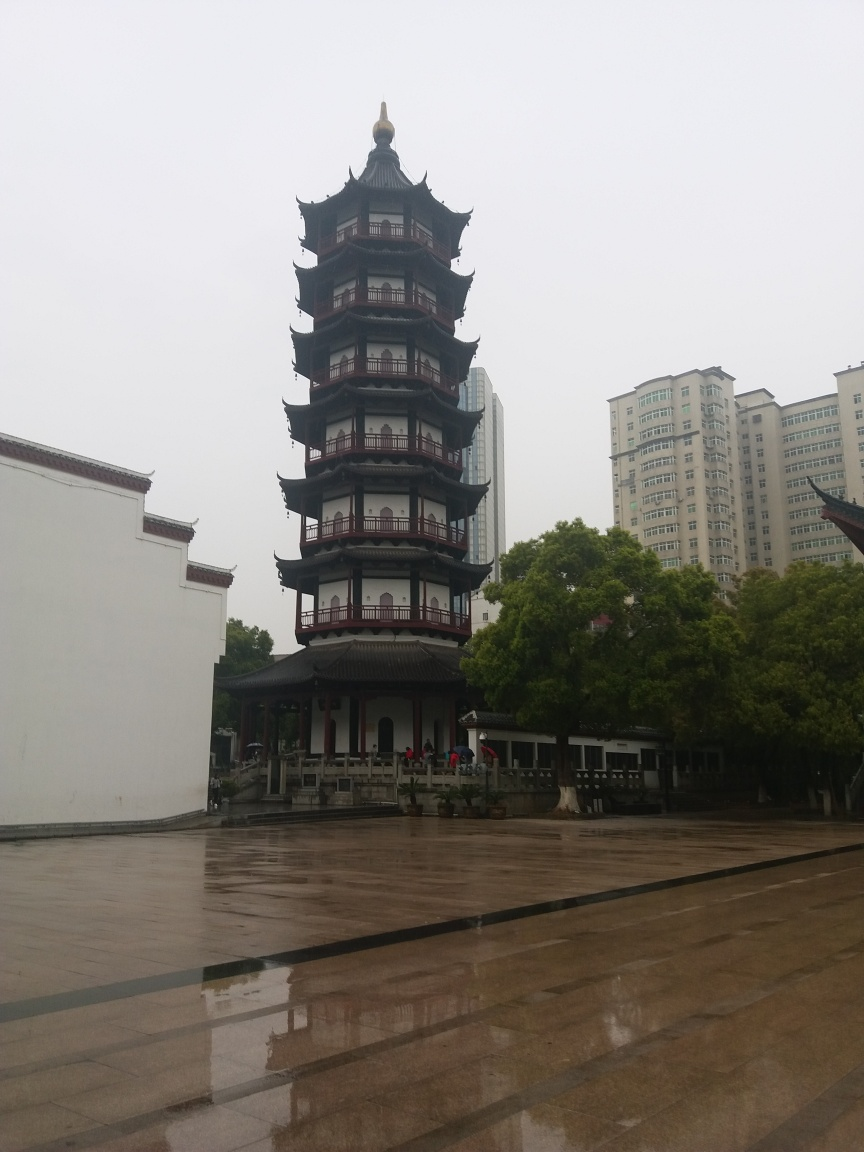Can you tell me about the weather conditions when the photo was taken? The photo appears to have been taken on an overcast day, as evidenced by the uniformly gray sky and the lack of shadows on the ground. The light is diffuse, which often happens when the sun is obscured by clouds, and the wet surfaces suggest that it might have been raining recently or that there is ongoing light rain. Does the weather affect the appearance of the image? Yes, the overcast conditions result in soft, natural lighting which eliminates harsh shadows and provides even illumination across the scene. However, this can also lead to less vibrant colors and lower contrast, making the image feel somewhat muted and lacking in depth. 